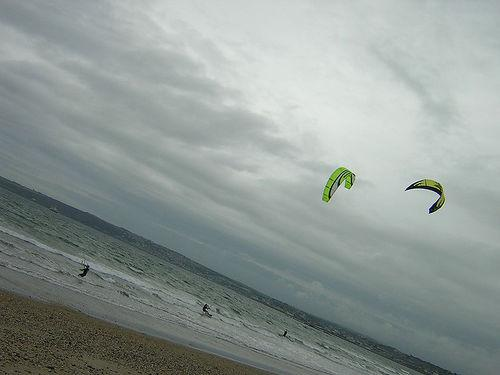Question: where was the photo taken?
Choices:
A. On the shore.
B. At the ocean.
C. On a beach.
D. By the sea.
Answer with the letter. Answer: C Question: what are the people flying?
Choices:
A. RC planes.
B. RC helicopters.
C. Kites.
D. Parasails.
Answer with the letter. Answer: C Question: why is it so bright?
Choices:
A. Sun light.
B. Too many lights.
C. It's Vegas.
D. Bad camera angle.
Answer with the letter. Answer: A 